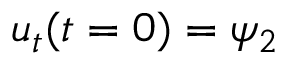<formula> <loc_0><loc_0><loc_500><loc_500>u _ { t } ( t = 0 ) = \psi _ { 2 }</formula> 